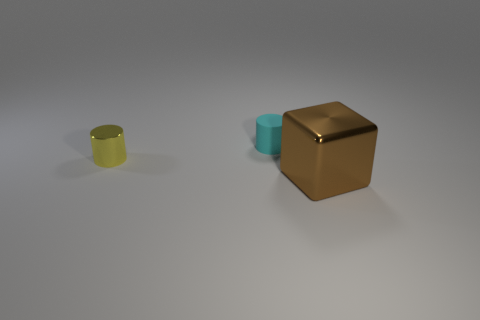What material is the other tiny object that is the same shape as the tiny rubber thing?
Your answer should be compact. Metal. What shape is the shiny object that is to the right of the object behind the metallic thing that is left of the brown object?
Keep it short and to the point. Cube. How many other things are the same shape as the small cyan rubber thing?
Your answer should be very brief. 1. There is a tiny cylinder right of the small yellow metallic thing; does it have the same color as the cylinder in front of the small cyan cylinder?
Give a very brief answer. No. What material is the other object that is the same size as the cyan object?
Provide a succinct answer. Metal. Is there a yellow metal cylinder that has the same size as the cyan matte thing?
Offer a terse response. Yes. Is the number of yellow cylinders that are right of the small rubber object less than the number of green things?
Offer a very short reply. No. Is the number of yellow things that are right of the cyan cylinder less than the number of yellow metal things that are to the left of the brown metallic block?
Offer a very short reply. Yes. What number of cubes are either tiny cyan objects or tiny yellow things?
Your answer should be very brief. 0. Is the material of the tiny thing to the left of the small cyan rubber thing the same as the cylinder on the right side of the tiny yellow shiny cylinder?
Your answer should be compact. No. 